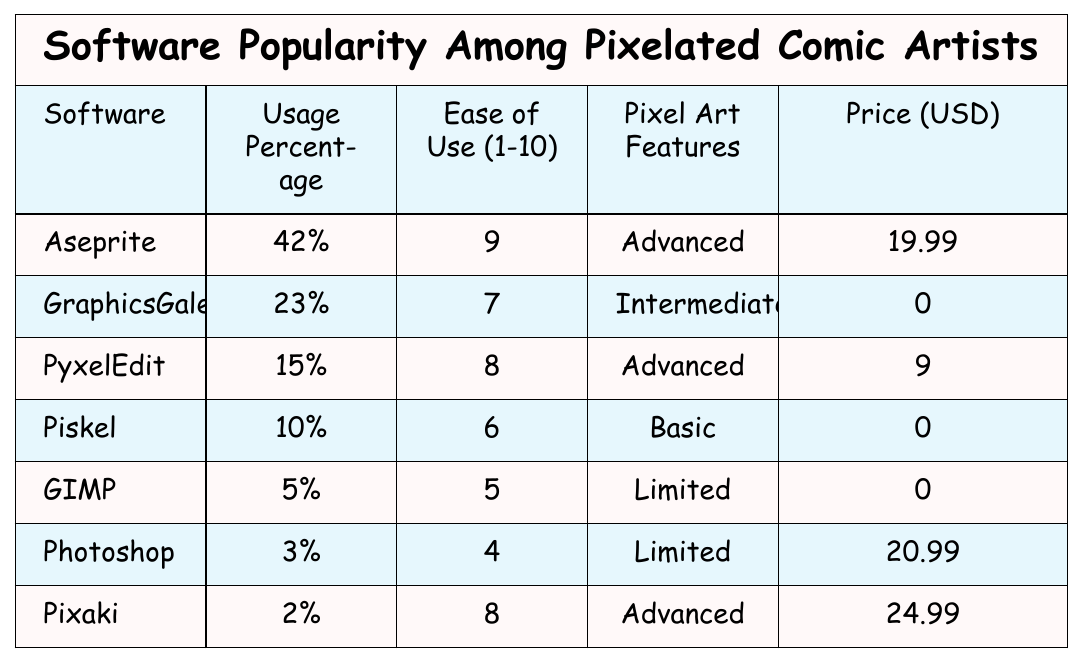What is the software with the highest usage percentage? The table lists the usage percentages of different software. Aseprite has 42%, which is higher than all other options listed.
Answer: Aseprite What is the price of GraphicsGale? The table shows that the price of GraphicsGale is listed as 0 USD.
Answer: 0 Which software has the lowest ease of use rating? In the Ease of Use column, Photoshop has the lowest rating of 4 out of 10.
Answer: Photoshop How many software have advanced pixel art features? By checking the "Pixel Art Features" column, Aseprite, PyxelEdit, and Pixaki are the three software that list "Advanced" as a feature.
Answer: 3 What is the average price of all the software listed? The total prices are 19.99 (Aseprite) + 0 (GraphicsGale) + 9 (PyxelEdit) + 0 (Piskel) + 0 (GIMP) + 20.99 (Photoshop) + 24.99 (Pixaki) = 74.97. There are 7 software listed, so the average is 74.97 / 7 ≈ 10.71.
Answer: 10.71 Is there any software that is free of charge? The table indicates that GraphicsGale, Piskel, and GIMP have a price of 0 USD, meaning they are free to use.
Answer: Yes What percentage of artists use Photoshop compared to Aseprite? Photoshop has a usage percentage of 3%, while Aseprite has 42%; to find the comparison: (3/42)*100 ≈ 7.14%, meaning about 7.14% of Aseprite users use Photoshop.
Answer: 7.14% What is the difference in usage percentage between Aseprite and Piskel? Aseprite's usage percentage is 42%, while Piskel's is 10%. The difference is 42% - 10% = 32%.
Answer: 32% Which software has both a high ease of use rating and advanced pixel art features? Aseprite and PyxelEdit both have ease of use ratings above 7 (Aseprite: 9, PyxelEdit: 8) and are classified as having advanced features.
Answer: Aseprite and PyxelEdit What is the most popular software among pixelated comic artists based on the usage percentage? Looking at the usage percentages, Aseprite at 42% is the most popular software listed.
Answer: Aseprite Is the ease of use rating correlated with the software price? While price varies (from 0 to 24.99 USD), the ease of use ratings also differ; for instance, free tools like GraphicsGale have a higher ease of use than some paid options. There is no clear correlation based on the table.
Answer: No 